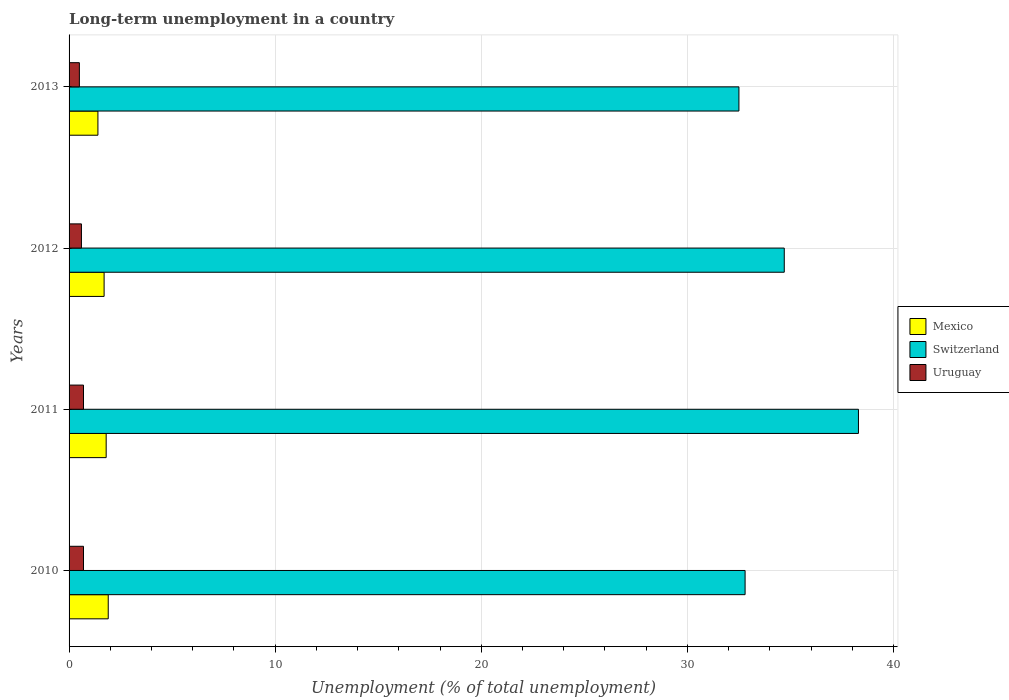How many groups of bars are there?
Give a very brief answer. 4. How many bars are there on the 2nd tick from the top?
Your answer should be very brief. 3. What is the percentage of long-term unemployed population in Uruguay in 2010?
Ensure brevity in your answer.  0.7. Across all years, what is the maximum percentage of long-term unemployed population in Mexico?
Your answer should be very brief. 1.9. In which year was the percentage of long-term unemployed population in Mexico minimum?
Offer a terse response. 2013. What is the total percentage of long-term unemployed population in Switzerland in the graph?
Offer a very short reply. 138.3. What is the difference between the percentage of long-term unemployed population in Uruguay in 2010 and that in 2012?
Give a very brief answer. 0.1. What is the difference between the percentage of long-term unemployed population in Mexico in 2010 and the percentage of long-term unemployed population in Uruguay in 2011?
Give a very brief answer. 1.2. What is the average percentage of long-term unemployed population in Mexico per year?
Keep it short and to the point. 1.7. In the year 2010, what is the difference between the percentage of long-term unemployed population in Uruguay and percentage of long-term unemployed population in Switzerland?
Your response must be concise. -32.1. In how many years, is the percentage of long-term unemployed population in Uruguay greater than 14 %?
Provide a short and direct response. 0. What is the ratio of the percentage of long-term unemployed population in Switzerland in 2010 to that in 2012?
Your answer should be very brief. 0.95. What is the difference between the highest and the second highest percentage of long-term unemployed population in Mexico?
Your answer should be compact. 0.1. What is the difference between the highest and the lowest percentage of long-term unemployed population in Switzerland?
Ensure brevity in your answer.  5.8. What does the 3rd bar from the top in 2013 represents?
Make the answer very short. Mexico. How many bars are there?
Offer a terse response. 12. Are all the bars in the graph horizontal?
Keep it short and to the point. Yes. How many years are there in the graph?
Provide a succinct answer. 4. Are the values on the major ticks of X-axis written in scientific E-notation?
Offer a terse response. No. Where does the legend appear in the graph?
Your response must be concise. Center right. How many legend labels are there?
Offer a terse response. 3. What is the title of the graph?
Ensure brevity in your answer.  Long-term unemployment in a country. Does "Palau" appear as one of the legend labels in the graph?
Offer a very short reply. No. What is the label or title of the X-axis?
Your response must be concise. Unemployment (% of total unemployment). What is the label or title of the Y-axis?
Provide a short and direct response. Years. What is the Unemployment (% of total unemployment) in Mexico in 2010?
Provide a succinct answer. 1.9. What is the Unemployment (% of total unemployment) in Switzerland in 2010?
Give a very brief answer. 32.8. What is the Unemployment (% of total unemployment) in Uruguay in 2010?
Your answer should be very brief. 0.7. What is the Unemployment (% of total unemployment) of Mexico in 2011?
Your response must be concise. 1.8. What is the Unemployment (% of total unemployment) of Switzerland in 2011?
Ensure brevity in your answer.  38.3. What is the Unemployment (% of total unemployment) in Uruguay in 2011?
Offer a terse response. 0.7. What is the Unemployment (% of total unemployment) of Mexico in 2012?
Keep it short and to the point. 1.7. What is the Unemployment (% of total unemployment) of Switzerland in 2012?
Make the answer very short. 34.7. What is the Unemployment (% of total unemployment) in Uruguay in 2012?
Provide a succinct answer. 0.6. What is the Unemployment (% of total unemployment) of Mexico in 2013?
Keep it short and to the point. 1.4. What is the Unemployment (% of total unemployment) in Switzerland in 2013?
Make the answer very short. 32.5. What is the Unemployment (% of total unemployment) in Uruguay in 2013?
Your response must be concise. 0.5. Across all years, what is the maximum Unemployment (% of total unemployment) in Mexico?
Provide a short and direct response. 1.9. Across all years, what is the maximum Unemployment (% of total unemployment) of Switzerland?
Your response must be concise. 38.3. Across all years, what is the maximum Unemployment (% of total unemployment) of Uruguay?
Your answer should be very brief. 0.7. Across all years, what is the minimum Unemployment (% of total unemployment) of Mexico?
Your answer should be very brief. 1.4. Across all years, what is the minimum Unemployment (% of total unemployment) in Switzerland?
Provide a short and direct response. 32.5. Across all years, what is the minimum Unemployment (% of total unemployment) in Uruguay?
Offer a terse response. 0.5. What is the total Unemployment (% of total unemployment) of Mexico in the graph?
Give a very brief answer. 6.8. What is the total Unemployment (% of total unemployment) of Switzerland in the graph?
Your answer should be compact. 138.3. What is the difference between the Unemployment (% of total unemployment) in Mexico in 2010 and that in 2011?
Provide a succinct answer. 0.1. What is the difference between the Unemployment (% of total unemployment) in Switzerland in 2010 and that in 2011?
Your answer should be compact. -5.5. What is the difference between the Unemployment (% of total unemployment) in Switzerland in 2010 and that in 2013?
Your answer should be very brief. 0.3. What is the difference between the Unemployment (% of total unemployment) in Uruguay in 2011 and that in 2012?
Keep it short and to the point. 0.1. What is the difference between the Unemployment (% of total unemployment) of Uruguay in 2011 and that in 2013?
Your answer should be very brief. 0.2. What is the difference between the Unemployment (% of total unemployment) in Mexico in 2010 and the Unemployment (% of total unemployment) in Switzerland in 2011?
Your answer should be compact. -36.4. What is the difference between the Unemployment (% of total unemployment) in Switzerland in 2010 and the Unemployment (% of total unemployment) in Uruguay in 2011?
Provide a short and direct response. 32.1. What is the difference between the Unemployment (% of total unemployment) of Mexico in 2010 and the Unemployment (% of total unemployment) of Switzerland in 2012?
Give a very brief answer. -32.8. What is the difference between the Unemployment (% of total unemployment) of Switzerland in 2010 and the Unemployment (% of total unemployment) of Uruguay in 2012?
Provide a short and direct response. 32.2. What is the difference between the Unemployment (% of total unemployment) in Mexico in 2010 and the Unemployment (% of total unemployment) in Switzerland in 2013?
Your answer should be compact. -30.6. What is the difference between the Unemployment (% of total unemployment) of Switzerland in 2010 and the Unemployment (% of total unemployment) of Uruguay in 2013?
Ensure brevity in your answer.  32.3. What is the difference between the Unemployment (% of total unemployment) in Mexico in 2011 and the Unemployment (% of total unemployment) in Switzerland in 2012?
Provide a succinct answer. -32.9. What is the difference between the Unemployment (% of total unemployment) of Mexico in 2011 and the Unemployment (% of total unemployment) of Uruguay in 2012?
Offer a terse response. 1.2. What is the difference between the Unemployment (% of total unemployment) of Switzerland in 2011 and the Unemployment (% of total unemployment) of Uruguay in 2012?
Your answer should be very brief. 37.7. What is the difference between the Unemployment (% of total unemployment) in Mexico in 2011 and the Unemployment (% of total unemployment) in Switzerland in 2013?
Offer a terse response. -30.7. What is the difference between the Unemployment (% of total unemployment) in Mexico in 2011 and the Unemployment (% of total unemployment) in Uruguay in 2013?
Offer a very short reply. 1.3. What is the difference between the Unemployment (% of total unemployment) of Switzerland in 2011 and the Unemployment (% of total unemployment) of Uruguay in 2013?
Keep it short and to the point. 37.8. What is the difference between the Unemployment (% of total unemployment) of Mexico in 2012 and the Unemployment (% of total unemployment) of Switzerland in 2013?
Ensure brevity in your answer.  -30.8. What is the difference between the Unemployment (% of total unemployment) of Switzerland in 2012 and the Unemployment (% of total unemployment) of Uruguay in 2013?
Your answer should be compact. 34.2. What is the average Unemployment (% of total unemployment) in Mexico per year?
Provide a succinct answer. 1.7. What is the average Unemployment (% of total unemployment) of Switzerland per year?
Your answer should be compact. 34.58. What is the average Unemployment (% of total unemployment) of Uruguay per year?
Give a very brief answer. 0.62. In the year 2010, what is the difference between the Unemployment (% of total unemployment) in Mexico and Unemployment (% of total unemployment) in Switzerland?
Make the answer very short. -30.9. In the year 2010, what is the difference between the Unemployment (% of total unemployment) in Mexico and Unemployment (% of total unemployment) in Uruguay?
Offer a terse response. 1.2. In the year 2010, what is the difference between the Unemployment (% of total unemployment) in Switzerland and Unemployment (% of total unemployment) in Uruguay?
Provide a short and direct response. 32.1. In the year 2011, what is the difference between the Unemployment (% of total unemployment) of Mexico and Unemployment (% of total unemployment) of Switzerland?
Give a very brief answer. -36.5. In the year 2011, what is the difference between the Unemployment (% of total unemployment) in Switzerland and Unemployment (% of total unemployment) in Uruguay?
Your response must be concise. 37.6. In the year 2012, what is the difference between the Unemployment (% of total unemployment) in Mexico and Unemployment (% of total unemployment) in Switzerland?
Make the answer very short. -33. In the year 2012, what is the difference between the Unemployment (% of total unemployment) of Mexico and Unemployment (% of total unemployment) of Uruguay?
Offer a terse response. 1.1. In the year 2012, what is the difference between the Unemployment (% of total unemployment) of Switzerland and Unemployment (% of total unemployment) of Uruguay?
Offer a terse response. 34.1. In the year 2013, what is the difference between the Unemployment (% of total unemployment) of Mexico and Unemployment (% of total unemployment) of Switzerland?
Offer a very short reply. -31.1. In the year 2013, what is the difference between the Unemployment (% of total unemployment) of Mexico and Unemployment (% of total unemployment) of Uruguay?
Make the answer very short. 0.9. In the year 2013, what is the difference between the Unemployment (% of total unemployment) of Switzerland and Unemployment (% of total unemployment) of Uruguay?
Ensure brevity in your answer.  32. What is the ratio of the Unemployment (% of total unemployment) in Mexico in 2010 to that in 2011?
Offer a terse response. 1.06. What is the ratio of the Unemployment (% of total unemployment) in Switzerland in 2010 to that in 2011?
Offer a terse response. 0.86. What is the ratio of the Unemployment (% of total unemployment) in Uruguay in 2010 to that in 2011?
Your answer should be very brief. 1. What is the ratio of the Unemployment (% of total unemployment) of Mexico in 2010 to that in 2012?
Provide a succinct answer. 1.12. What is the ratio of the Unemployment (% of total unemployment) of Switzerland in 2010 to that in 2012?
Give a very brief answer. 0.95. What is the ratio of the Unemployment (% of total unemployment) of Mexico in 2010 to that in 2013?
Offer a very short reply. 1.36. What is the ratio of the Unemployment (% of total unemployment) of Switzerland in 2010 to that in 2013?
Make the answer very short. 1.01. What is the ratio of the Unemployment (% of total unemployment) of Mexico in 2011 to that in 2012?
Offer a very short reply. 1.06. What is the ratio of the Unemployment (% of total unemployment) in Switzerland in 2011 to that in 2012?
Give a very brief answer. 1.1. What is the ratio of the Unemployment (% of total unemployment) in Switzerland in 2011 to that in 2013?
Your answer should be compact. 1.18. What is the ratio of the Unemployment (% of total unemployment) in Uruguay in 2011 to that in 2013?
Make the answer very short. 1.4. What is the ratio of the Unemployment (% of total unemployment) of Mexico in 2012 to that in 2013?
Your answer should be compact. 1.21. What is the ratio of the Unemployment (% of total unemployment) of Switzerland in 2012 to that in 2013?
Keep it short and to the point. 1.07. What is the ratio of the Unemployment (% of total unemployment) in Uruguay in 2012 to that in 2013?
Your response must be concise. 1.2. What is the difference between the highest and the second highest Unemployment (% of total unemployment) in Switzerland?
Provide a short and direct response. 3.6. What is the difference between the highest and the lowest Unemployment (% of total unemployment) of Mexico?
Offer a terse response. 0.5. What is the difference between the highest and the lowest Unemployment (% of total unemployment) in Uruguay?
Keep it short and to the point. 0.2. 